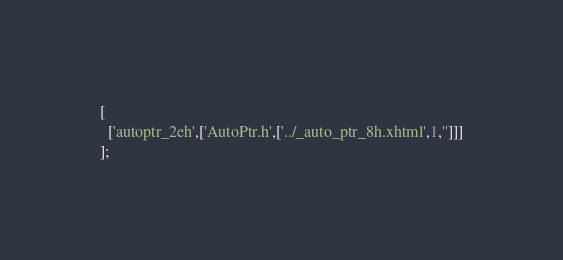Convert code to text. <code><loc_0><loc_0><loc_500><loc_500><_JavaScript_>[
  ['autoptr_2eh',['AutoPtr.h',['../_auto_ptr_8h.xhtml',1,'']]]
];
</code> 